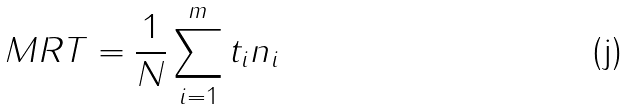<formula> <loc_0><loc_0><loc_500><loc_500>M R T = \frac { 1 } { N } \sum _ { i = 1 } ^ { m } t _ { i } n _ { i }</formula> 